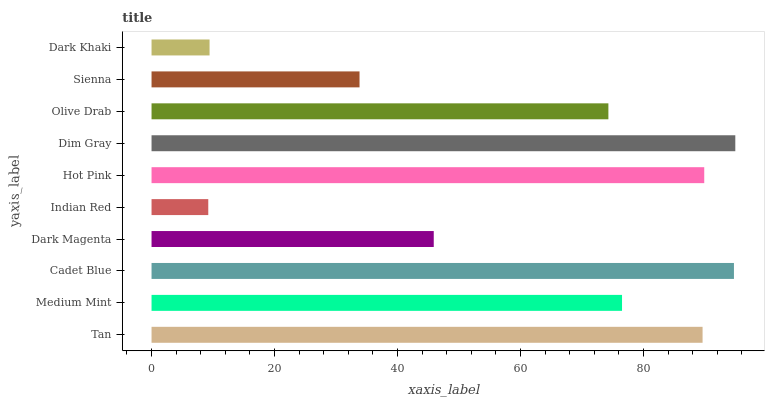Is Indian Red the minimum?
Answer yes or no. Yes. Is Dim Gray the maximum?
Answer yes or no. Yes. Is Medium Mint the minimum?
Answer yes or no. No. Is Medium Mint the maximum?
Answer yes or no. No. Is Tan greater than Medium Mint?
Answer yes or no. Yes. Is Medium Mint less than Tan?
Answer yes or no. Yes. Is Medium Mint greater than Tan?
Answer yes or no. No. Is Tan less than Medium Mint?
Answer yes or no. No. Is Medium Mint the high median?
Answer yes or no. Yes. Is Olive Drab the low median?
Answer yes or no. Yes. Is Sienna the high median?
Answer yes or no. No. Is Hot Pink the low median?
Answer yes or no. No. 